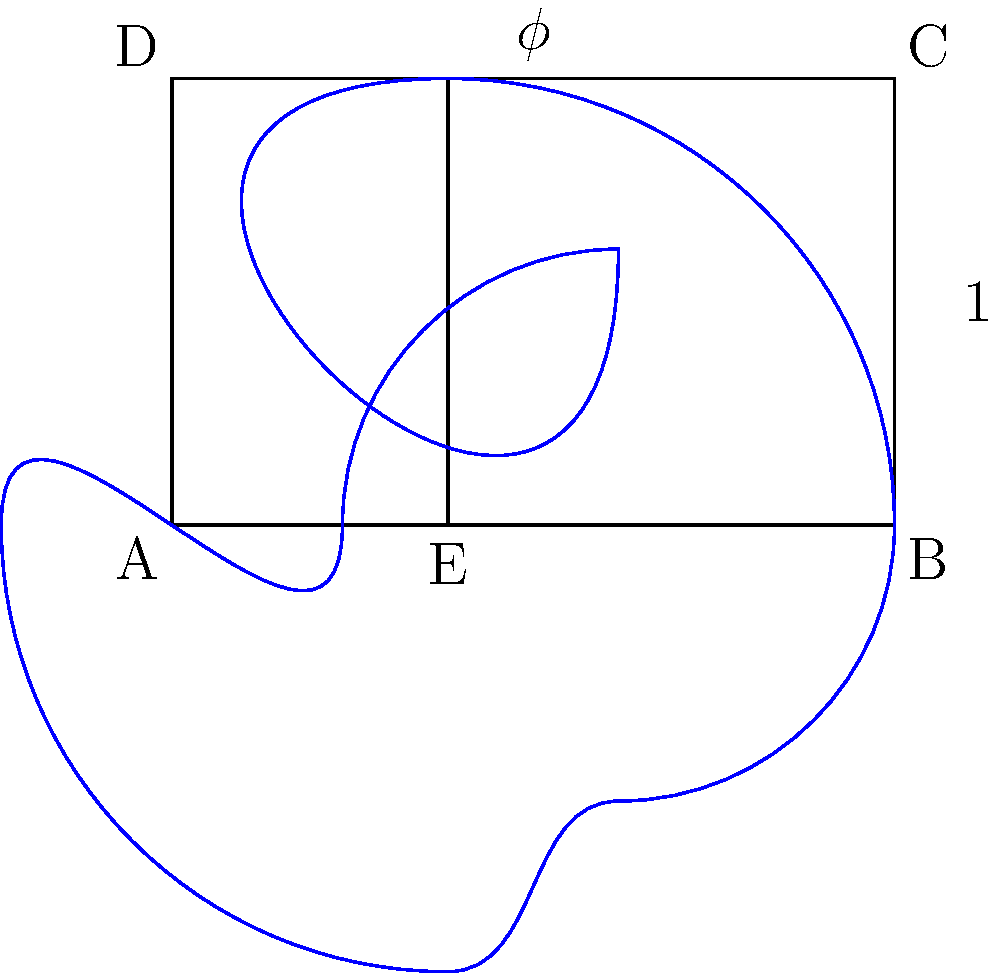In Hokusai's "The Great Wave off Kanagawa", the golden ratio is used to create a harmonious composition. If the width of the painting is represented by 1, what is the height of the golden rectangle that forms the main compositional structure? To determine the height of the golden rectangle based on a width of 1, we need to understand the properties of the golden ratio:

1. The golden ratio, denoted by $\phi$ (phi), is approximately equal to 1.618.

2. In a golden rectangle, the ratio of the longer side to the shorter side is equal to $\phi$.

3. If we set the width of the rectangle to 1, we can express the height as $\frac{1}{\phi}$.

4. The value of $\phi$ can be calculated using the formula:

   $$\phi = \frac{1 + \sqrt{5}}{2}$$

5. Substituting this value:

   $$\text{Height} = \frac{1}{\phi} = \frac{2}{1 + \sqrt{5}}$$

6. Simplifying:

   $$\text{Height} = \frac{2}{1 + \sqrt{5}} \approx 0.618$$

Therefore, if the width of the painting is represented by 1, the height of the golden rectangle that forms the main compositional structure would be approximately 0.618.
Answer: $\frac{1}{\phi}$ or $\frac{2}{1 + \sqrt{5}}$ (approximately 0.618) 